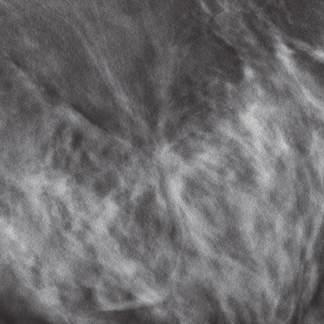does bowing of legs appear as relatively subtle, irregular masses in mammograms?
Answer the question using a single word or phrase. No 